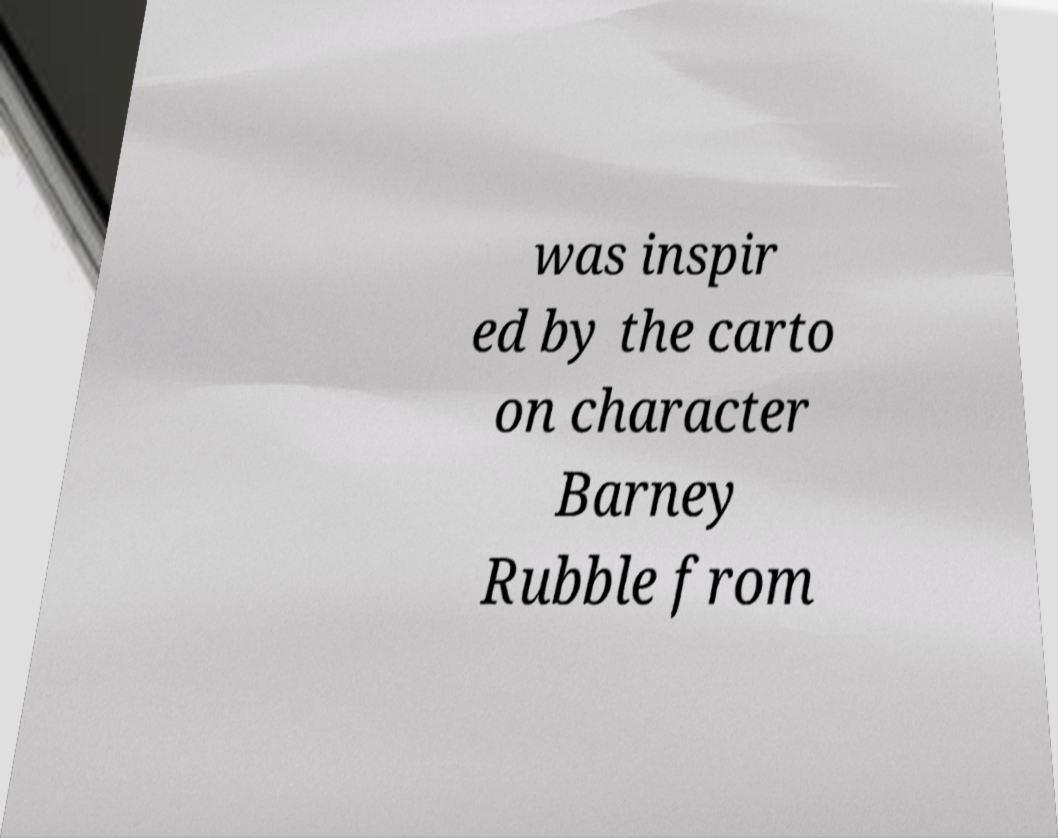What messages or text are displayed in this image? I need them in a readable, typed format. was inspir ed by the carto on character Barney Rubble from 